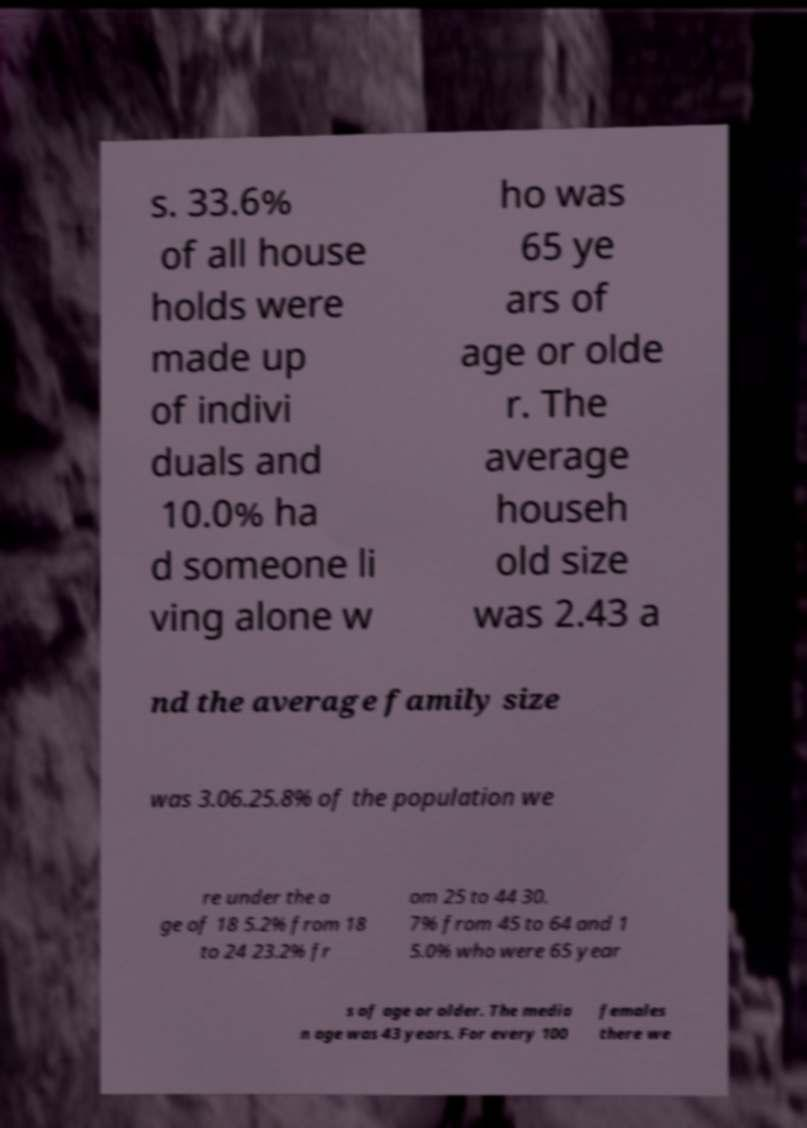There's text embedded in this image that I need extracted. Can you transcribe it verbatim? s. 33.6% of all house holds were made up of indivi duals and 10.0% ha d someone li ving alone w ho was 65 ye ars of age or olde r. The average househ old size was 2.43 a nd the average family size was 3.06.25.8% of the population we re under the a ge of 18 5.2% from 18 to 24 23.2% fr om 25 to 44 30. 7% from 45 to 64 and 1 5.0% who were 65 year s of age or older. The media n age was 43 years. For every 100 females there we 